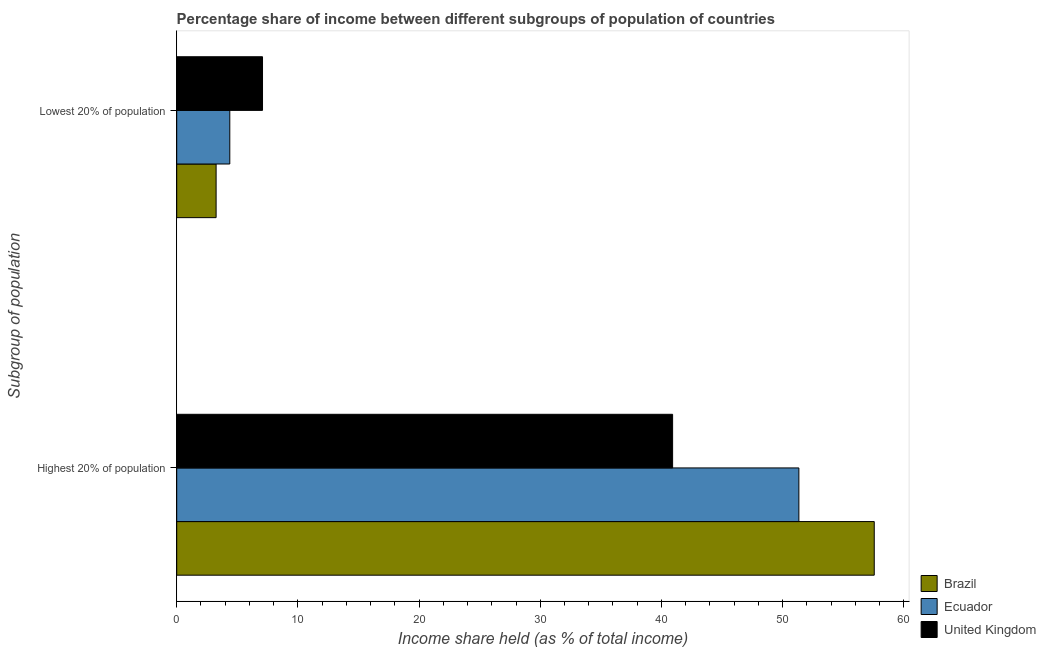How many groups of bars are there?
Give a very brief answer. 2. Are the number of bars on each tick of the Y-axis equal?
Provide a short and direct response. Yes. How many bars are there on the 2nd tick from the top?
Ensure brevity in your answer.  3. How many bars are there on the 1st tick from the bottom?
Ensure brevity in your answer.  3. What is the label of the 1st group of bars from the top?
Your response must be concise. Lowest 20% of population. What is the income share held by lowest 20% of the population in United Kingdom?
Give a very brief answer. 7.08. Across all countries, what is the maximum income share held by highest 20% of the population?
Offer a terse response. 57.56. Across all countries, what is the minimum income share held by highest 20% of the population?
Offer a terse response. 40.92. What is the total income share held by lowest 20% of the population in the graph?
Make the answer very short. 14.71. What is the difference between the income share held by lowest 20% of the population in Ecuador and that in United Kingdom?
Make the answer very short. -2.7. What is the difference between the income share held by highest 20% of the population in Ecuador and the income share held by lowest 20% of the population in United Kingdom?
Your answer should be compact. 44.26. What is the average income share held by lowest 20% of the population per country?
Make the answer very short. 4.9. What is the difference between the income share held by lowest 20% of the population and income share held by highest 20% of the population in United Kingdom?
Offer a terse response. -33.84. In how many countries, is the income share held by highest 20% of the population greater than 10 %?
Offer a terse response. 3. What is the ratio of the income share held by lowest 20% of the population in United Kingdom to that in Ecuador?
Give a very brief answer. 1.62. Is the income share held by highest 20% of the population in Brazil less than that in United Kingdom?
Your answer should be compact. No. What does the 1st bar from the top in Highest 20% of population represents?
Your response must be concise. United Kingdom. What does the 2nd bar from the bottom in Lowest 20% of population represents?
Offer a very short reply. Ecuador. How many countries are there in the graph?
Offer a very short reply. 3. What is the difference between two consecutive major ticks on the X-axis?
Provide a short and direct response. 10. Are the values on the major ticks of X-axis written in scientific E-notation?
Give a very brief answer. No. Where does the legend appear in the graph?
Offer a terse response. Bottom right. What is the title of the graph?
Provide a succinct answer. Percentage share of income between different subgroups of population of countries. Does "Papua New Guinea" appear as one of the legend labels in the graph?
Offer a very short reply. No. What is the label or title of the X-axis?
Offer a very short reply. Income share held (as % of total income). What is the label or title of the Y-axis?
Provide a succinct answer. Subgroup of population. What is the Income share held (as % of total income) of Brazil in Highest 20% of population?
Your answer should be compact. 57.56. What is the Income share held (as % of total income) of Ecuador in Highest 20% of population?
Make the answer very short. 51.34. What is the Income share held (as % of total income) of United Kingdom in Highest 20% of population?
Make the answer very short. 40.92. What is the Income share held (as % of total income) of Brazil in Lowest 20% of population?
Offer a terse response. 3.25. What is the Income share held (as % of total income) of Ecuador in Lowest 20% of population?
Provide a short and direct response. 4.38. What is the Income share held (as % of total income) of United Kingdom in Lowest 20% of population?
Offer a terse response. 7.08. Across all Subgroup of population, what is the maximum Income share held (as % of total income) in Brazil?
Offer a terse response. 57.56. Across all Subgroup of population, what is the maximum Income share held (as % of total income) in Ecuador?
Make the answer very short. 51.34. Across all Subgroup of population, what is the maximum Income share held (as % of total income) of United Kingdom?
Ensure brevity in your answer.  40.92. Across all Subgroup of population, what is the minimum Income share held (as % of total income) in Brazil?
Offer a terse response. 3.25. Across all Subgroup of population, what is the minimum Income share held (as % of total income) of Ecuador?
Give a very brief answer. 4.38. Across all Subgroup of population, what is the minimum Income share held (as % of total income) in United Kingdom?
Provide a succinct answer. 7.08. What is the total Income share held (as % of total income) in Brazil in the graph?
Provide a short and direct response. 60.81. What is the total Income share held (as % of total income) in Ecuador in the graph?
Your response must be concise. 55.72. What is the total Income share held (as % of total income) in United Kingdom in the graph?
Give a very brief answer. 48. What is the difference between the Income share held (as % of total income) of Brazil in Highest 20% of population and that in Lowest 20% of population?
Offer a terse response. 54.31. What is the difference between the Income share held (as % of total income) in Ecuador in Highest 20% of population and that in Lowest 20% of population?
Offer a very short reply. 46.96. What is the difference between the Income share held (as % of total income) of United Kingdom in Highest 20% of population and that in Lowest 20% of population?
Your answer should be very brief. 33.84. What is the difference between the Income share held (as % of total income) of Brazil in Highest 20% of population and the Income share held (as % of total income) of Ecuador in Lowest 20% of population?
Ensure brevity in your answer.  53.18. What is the difference between the Income share held (as % of total income) of Brazil in Highest 20% of population and the Income share held (as % of total income) of United Kingdom in Lowest 20% of population?
Ensure brevity in your answer.  50.48. What is the difference between the Income share held (as % of total income) of Ecuador in Highest 20% of population and the Income share held (as % of total income) of United Kingdom in Lowest 20% of population?
Provide a succinct answer. 44.26. What is the average Income share held (as % of total income) in Brazil per Subgroup of population?
Your answer should be compact. 30.41. What is the average Income share held (as % of total income) of Ecuador per Subgroup of population?
Make the answer very short. 27.86. What is the average Income share held (as % of total income) in United Kingdom per Subgroup of population?
Your answer should be compact. 24. What is the difference between the Income share held (as % of total income) in Brazil and Income share held (as % of total income) in Ecuador in Highest 20% of population?
Keep it short and to the point. 6.22. What is the difference between the Income share held (as % of total income) in Brazil and Income share held (as % of total income) in United Kingdom in Highest 20% of population?
Ensure brevity in your answer.  16.64. What is the difference between the Income share held (as % of total income) of Ecuador and Income share held (as % of total income) of United Kingdom in Highest 20% of population?
Ensure brevity in your answer.  10.42. What is the difference between the Income share held (as % of total income) of Brazil and Income share held (as % of total income) of Ecuador in Lowest 20% of population?
Offer a terse response. -1.13. What is the difference between the Income share held (as % of total income) in Brazil and Income share held (as % of total income) in United Kingdom in Lowest 20% of population?
Ensure brevity in your answer.  -3.83. What is the ratio of the Income share held (as % of total income) in Brazil in Highest 20% of population to that in Lowest 20% of population?
Keep it short and to the point. 17.71. What is the ratio of the Income share held (as % of total income) in Ecuador in Highest 20% of population to that in Lowest 20% of population?
Offer a terse response. 11.72. What is the ratio of the Income share held (as % of total income) of United Kingdom in Highest 20% of population to that in Lowest 20% of population?
Ensure brevity in your answer.  5.78. What is the difference between the highest and the second highest Income share held (as % of total income) in Brazil?
Your answer should be compact. 54.31. What is the difference between the highest and the second highest Income share held (as % of total income) in Ecuador?
Your response must be concise. 46.96. What is the difference between the highest and the second highest Income share held (as % of total income) in United Kingdom?
Make the answer very short. 33.84. What is the difference between the highest and the lowest Income share held (as % of total income) of Brazil?
Make the answer very short. 54.31. What is the difference between the highest and the lowest Income share held (as % of total income) of Ecuador?
Keep it short and to the point. 46.96. What is the difference between the highest and the lowest Income share held (as % of total income) in United Kingdom?
Provide a short and direct response. 33.84. 